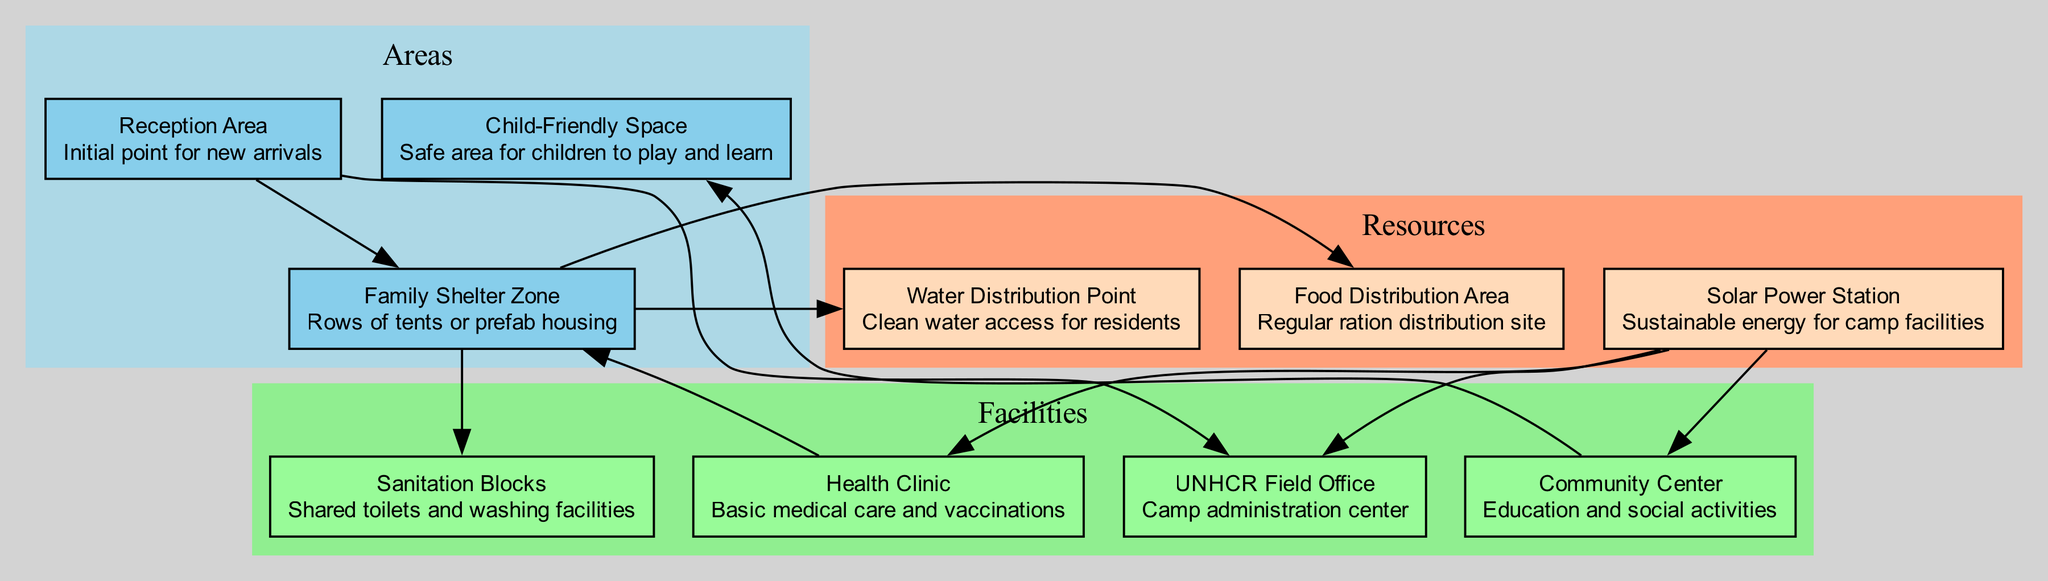What is the initial point for new arrivals? The diagram identifies the "Reception Area" as the initial point for new arrivals. This is the first area that refugees encounter upon entering the camp.
Answer: Reception Area How many types of facilities are in the diagram? By reviewing the diagram elements, we observe there are three types of facilities: UNHCR Field Office, Health Clinic, Community Center, and Sanitation Blocks, totaling four facilities.
Answer: 4 Which area connects to both the Health Clinic and the Family Shelter Zone? The Family Shelter Zone connects to the Health Clinic in addition to other resources like the Water Distribution Point. Both areas show a direct connection in the diagram.
Answer: Family Shelter Zone What resource provides clean water access for residents? The diagram specifies the "Water Distribution Point" as the resource that provides clean water access for camp residents, ensuring their hydration needs are met.
Answer: Water Distribution Point Which area is designated for education and social activities? The "Community Center" is designated for education and social activities, serving as a hub for the residents to engage and learn. This is shown clearly in the diagram.
Answer: Community Center How many connection lines are there between the Family Shelter Zone and other facilities/resources? The Family Shelter Zone is connected by three lines: to the Water Distribution Point, Food Distribution Area, and Sanitation Blocks, indicating the vital resources available for families.
Answer: 3 What area in the camp is specifically for children's activities? The "Child-Friendly Space" is marked in the diagram as the area specifically designated for children's activities, promoting safety and play in a secure environment.
Answer: Child-Friendly Space How does the Solar Power Station interact with other facilities? The Solar Power Station connects to three facilities: the UNHCR Field Office, Health Clinic, and Community Center. This indicates its critical role in providing sustainable energy to these facilities.
Answer: 3 connections 